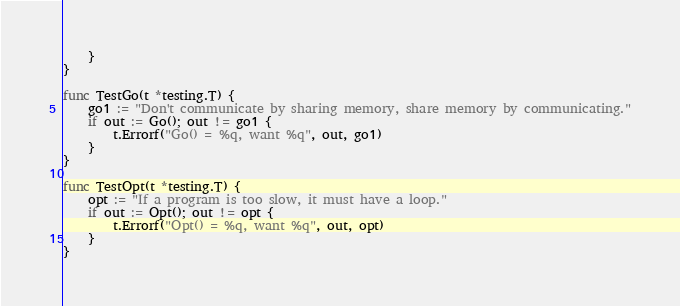<code> <loc_0><loc_0><loc_500><loc_500><_Go_>	}
}

func TestGo(t *testing.T) {
	go1 := "Don't communicate by sharing memory, share memory by communicating."
	if out := Go(); out != go1 {
		t.Errorf("Go() = %q, want %q", out, go1)
	}
}

func TestOpt(t *testing.T) {
	opt := "If a program is too slow, it must have a loop."
	if out := Opt(); out != opt {
		t.Errorf("Opt() = %q, want %q", out, opt)
	}
}
</code> 